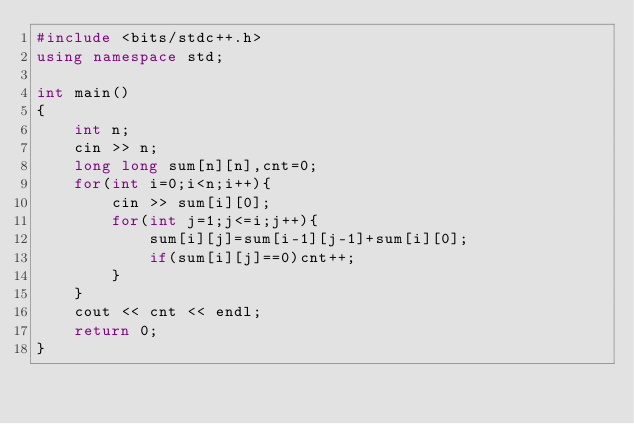Convert code to text. <code><loc_0><loc_0><loc_500><loc_500><_C++_>#include <bits/stdc++.h>
using namespace std;

int main()
{
    int n;
    cin >> n;
    long long sum[n][n],cnt=0;
    for(int i=0;i<n;i++){
        cin >> sum[i][0];
        for(int j=1;j<=i;j++){
            sum[i][j]=sum[i-1][j-1]+sum[i][0];
            if(sum[i][j]==0)cnt++;
        }
    }
    cout << cnt << endl;
    return 0;
}</code> 